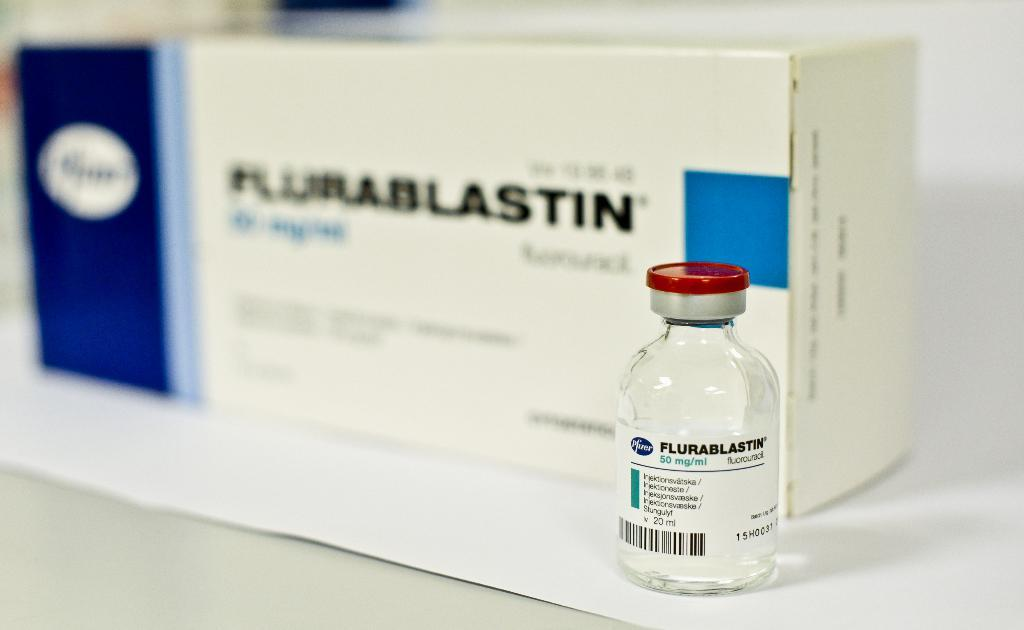Provide a one-sentence caption for the provided image. a small bottle of flurablastin in front of a box of flurablastin. 